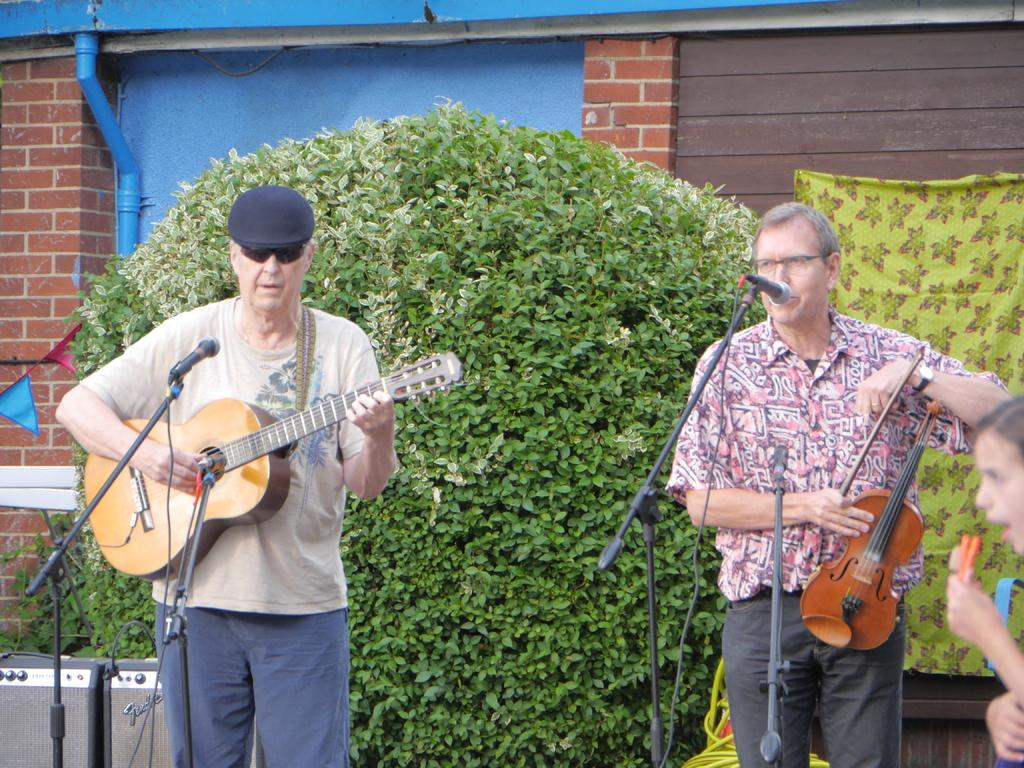What are the people in the image doing? The people in the image are playing musical instruments. What can be seen in front of the people playing musical instruments? There are mice in front of the people playing musical instruments. What is visible in the background of the image? There is a plant and a red-colored building in the background of the image. What is the range of the lip in the image? There is no lip present in the image, so it is not possible to determine its range. 